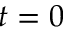Convert formula to latex. <formula><loc_0><loc_0><loc_500><loc_500>t = 0</formula> 